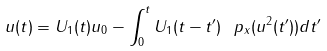<formula> <loc_0><loc_0><loc_500><loc_500>u ( t ) = U _ { 1 } ( t ) u _ { 0 } - \int _ { 0 } ^ { t } U _ { 1 } ( t - t ^ { \prime } ) \ p _ { x } ( u ^ { 2 } ( t ^ { \prime } ) ) d t ^ { \prime }</formula> 